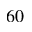<formula> <loc_0><loc_0><loc_500><loc_500>^ { 6 0 }</formula> 